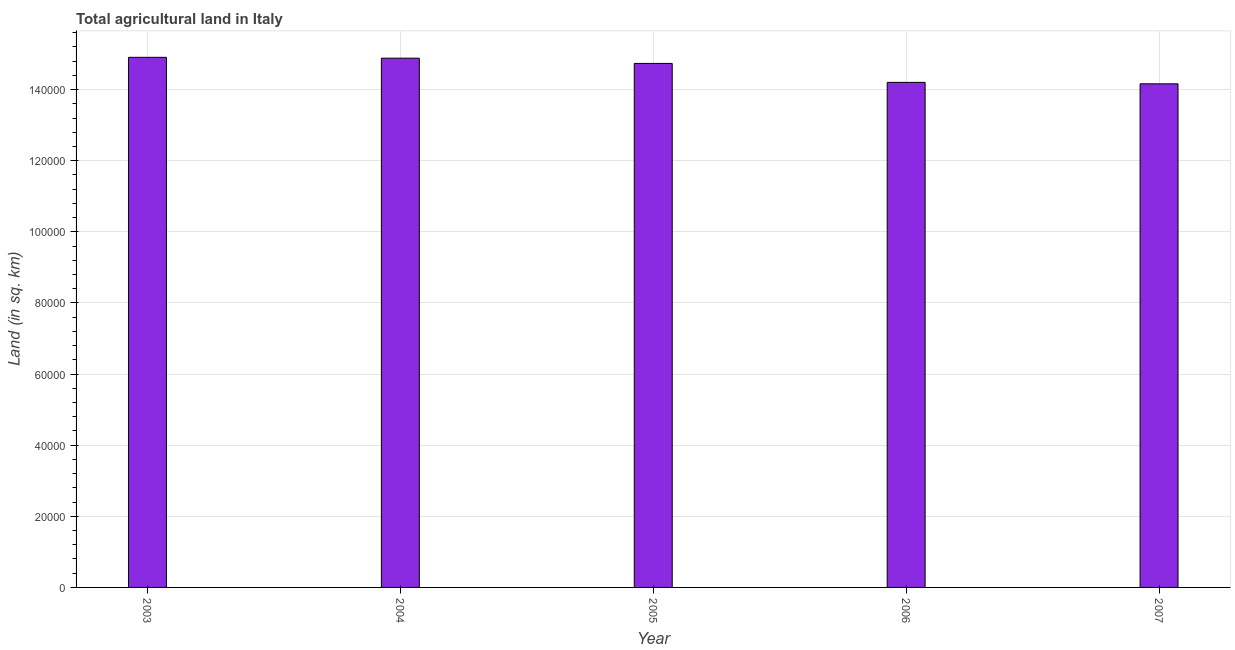Does the graph contain any zero values?
Provide a short and direct response. No. Does the graph contain grids?
Keep it short and to the point. Yes. What is the title of the graph?
Keep it short and to the point. Total agricultural land in Italy. What is the label or title of the Y-axis?
Offer a terse response. Land (in sq. km). What is the agricultural land in 2003?
Your response must be concise. 1.49e+05. Across all years, what is the maximum agricultural land?
Offer a very short reply. 1.49e+05. Across all years, what is the minimum agricultural land?
Your answer should be compact. 1.42e+05. What is the sum of the agricultural land?
Your answer should be very brief. 7.29e+05. What is the difference between the agricultural land in 2004 and 2006?
Offer a very short reply. 6800. What is the average agricultural land per year?
Your response must be concise. 1.46e+05. What is the median agricultural land?
Make the answer very short. 1.47e+05. What is the ratio of the agricultural land in 2005 to that in 2007?
Give a very brief answer. 1.04. Is the agricultural land in 2006 less than that in 2007?
Your answer should be compact. No. What is the difference between the highest and the second highest agricultural land?
Make the answer very short. 240. What is the difference between the highest and the lowest agricultural land?
Give a very brief answer. 7450. In how many years, is the agricultural land greater than the average agricultural land taken over all years?
Offer a very short reply. 3. How many bars are there?
Offer a terse response. 5. Are all the bars in the graph horizontal?
Give a very brief answer. No. What is the Land (in sq. km) in 2003?
Give a very brief answer. 1.49e+05. What is the Land (in sq. km) of 2004?
Keep it short and to the point. 1.49e+05. What is the Land (in sq. km) of 2005?
Your response must be concise. 1.47e+05. What is the Land (in sq. km) in 2006?
Provide a succinct answer. 1.42e+05. What is the Land (in sq. km) in 2007?
Ensure brevity in your answer.  1.42e+05. What is the difference between the Land (in sq. km) in 2003 and 2004?
Offer a very short reply. 240. What is the difference between the Land (in sq. km) in 2003 and 2005?
Offer a very short reply. 1710. What is the difference between the Land (in sq. km) in 2003 and 2006?
Provide a short and direct response. 7040. What is the difference between the Land (in sq. km) in 2003 and 2007?
Your response must be concise. 7450. What is the difference between the Land (in sq. km) in 2004 and 2005?
Your response must be concise. 1470. What is the difference between the Land (in sq. km) in 2004 and 2006?
Provide a succinct answer. 6800. What is the difference between the Land (in sq. km) in 2004 and 2007?
Your response must be concise. 7210. What is the difference between the Land (in sq. km) in 2005 and 2006?
Keep it short and to the point. 5330. What is the difference between the Land (in sq. km) in 2005 and 2007?
Your response must be concise. 5740. What is the difference between the Land (in sq. km) in 2006 and 2007?
Offer a very short reply. 410. What is the ratio of the Land (in sq. km) in 2003 to that in 2004?
Your response must be concise. 1. What is the ratio of the Land (in sq. km) in 2003 to that in 2005?
Make the answer very short. 1.01. What is the ratio of the Land (in sq. km) in 2003 to that in 2006?
Give a very brief answer. 1.05. What is the ratio of the Land (in sq. km) in 2003 to that in 2007?
Your response must be concise. 1.05. What is the ratio of the Land (in sq. km) in 2004 to that in 2005?
Provide a succinct answer. 1.01. What is the ratio of the Land (in sq. km) in 2004 to that in 2006?
Offer a very short reply. 1.05. What is the ratio of the Land (in sq. km) in 2004 to that in 2007?
Your response must be concise. 1.05. What is the ratio of the Land (in sq. km) in 2005 to that in 2006?
Your answer should be very brief. 1.04. What is the ratio of the Land (in sq. km) in 2005 to that in 2007?
Your answer should be very brief. 1.04. What is the ratio of the Land (in sq. km) in 2006 to that in 2007?
Keep it short and to the point. 1. 